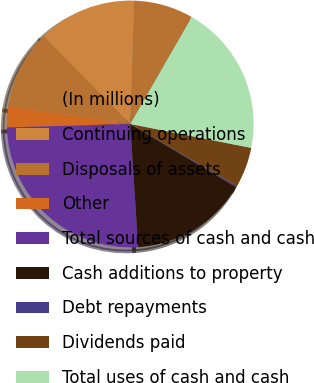Convert chart. <chart><loc_0><loc_0><loc_500><loc_500><pie_chart><fcel>(In millions)<fcel>Continuing operations<fcel>Disposals of assets<fcel>Other<fcel>Total sources of cash and cash<fcel>Cash additions to property<fcel>Debt repayments<fcel>Dividends paid<fcel>Total uses of cash and cash<nl><fcel>7.8%<fcel>12.88%<fcel>10.34%<fcel>2.72%<fcel>25.58%<fcel>15.42%<fcel>0.18%<fcel>5.26%<fcel>19.81%<nl></chart> 